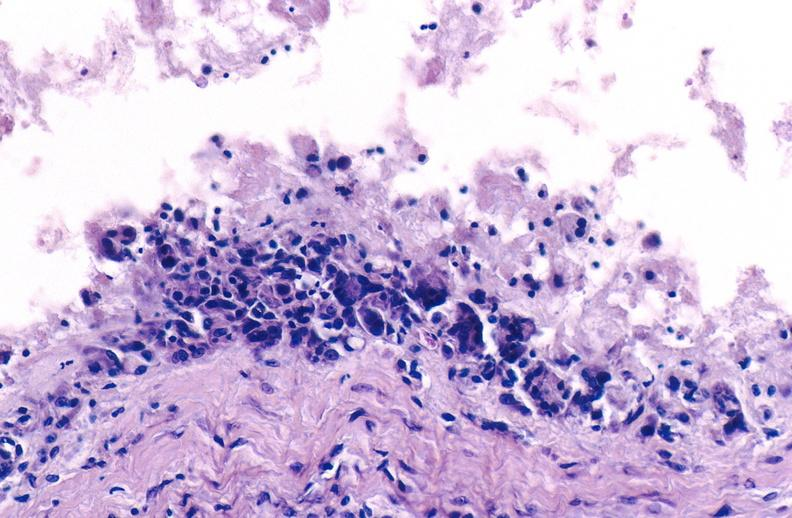what does this image show?
Answer the question using a single word or phrase. Gout 